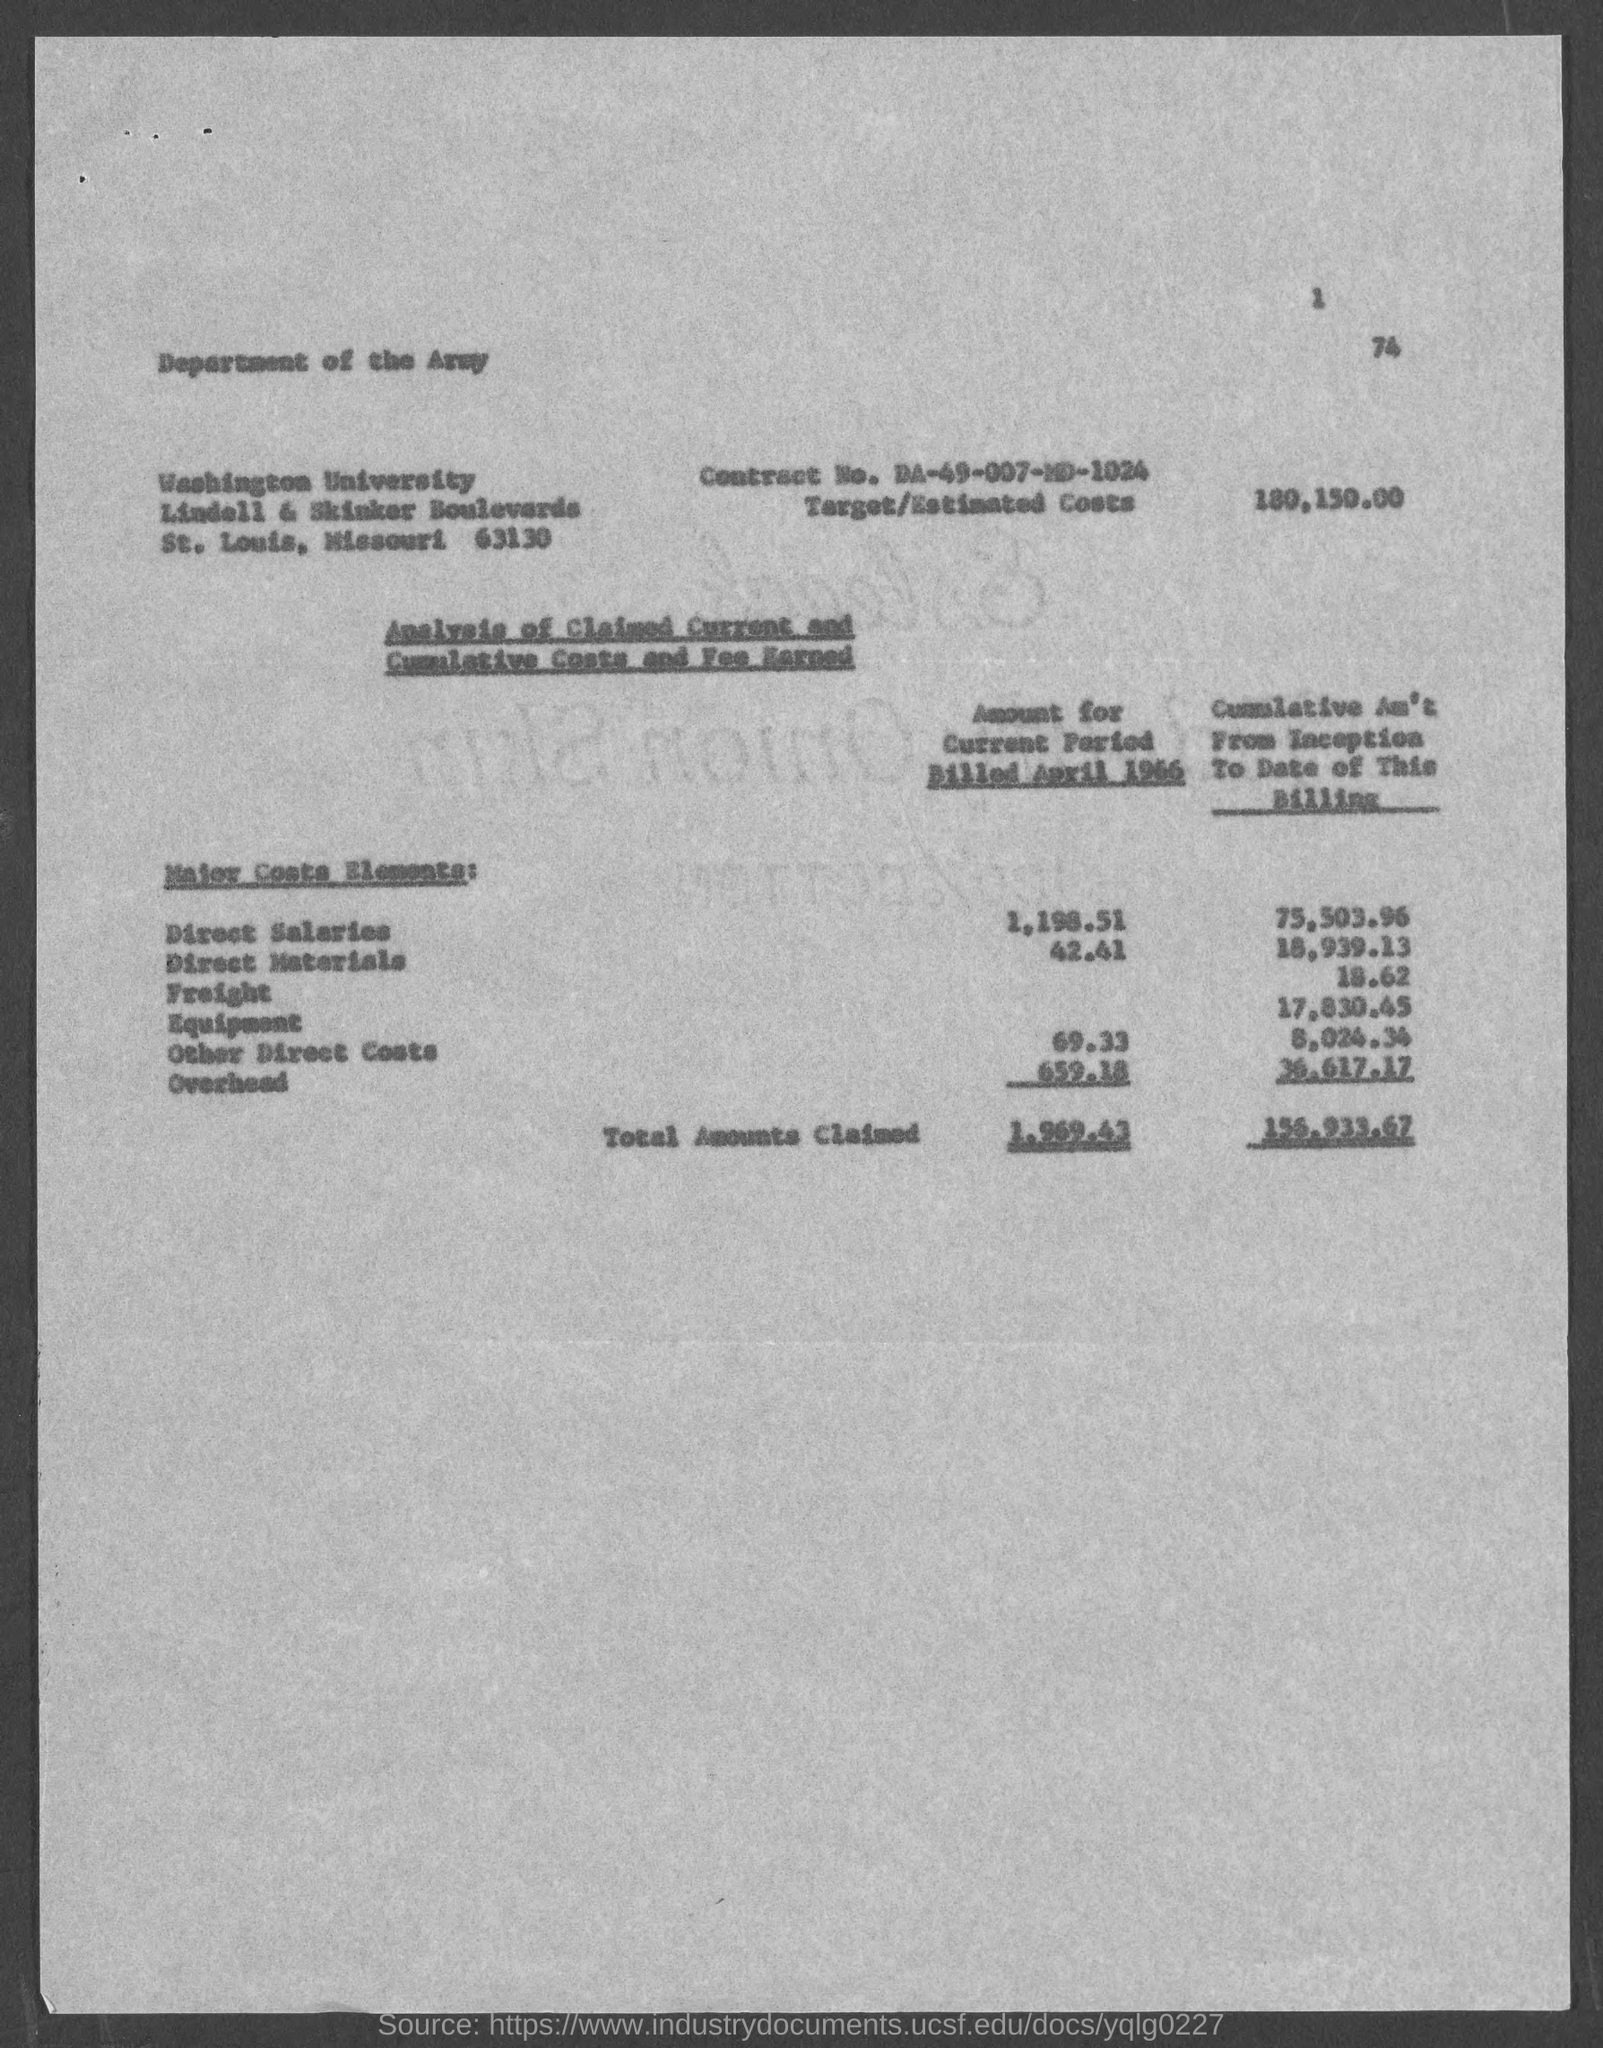What is the page number at top of the page?
Your response must be concise. 1. What is the contract no.?
Give a very brief answer. DA-49-007-MD-1024. What is the target/estimated costs ?
Offer a terse response. $180,150.00. 